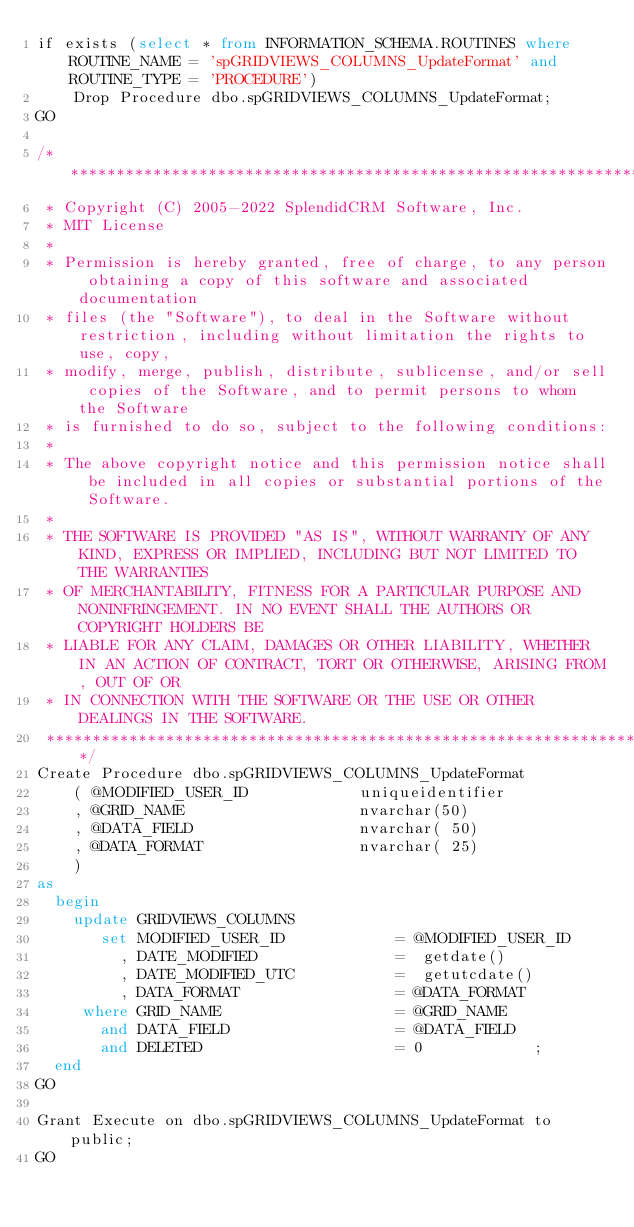Convert code to text. <code><loc_0><loc_0><loc_500><loc_500><_SQL_>if exists (select * from INFORMATION_SCHEMA.ROUTINES where ROUTINE_NAME = 'spGRIDVIEWS_COLUMNS_UpdateFormat' and ROUTINE_TYPE = 'PROCEDURE')
	Drop Procedure dbo.spGRIDVIEWS_COLUMNS_UpdateFormat;
GO
 
/**********************************************************************************************************************
 * Copyright (C) 2005-2022 SplendidCRM Software, Inc. 
 * MIT License
 * 
 * Permission is hereby granted, free of charge, to any person obtaining a copy of this software and associated documentation 
 * files (the "Software"), to deal in the Software without restriction, including without limitation the rights to use, copy, 
 * modify, merge, publish, distribute, sublicense, and/or sell copies of the Software, and to permit persons to whom the Software 
 * is furnished to do so, subject to the following conditions:
 * 
 * The above copyright notice and this permission notice shall be included in all copies or substantial portions of the Software.
 * 
 * THE SOFTWARE IS PROVIDED "AS IS", WITHOUT WARRANTY OF ANY KIND, EXPRESS OR IMPLIED, INCLUDING BUT NOT LIMITED TO THE WARRANTIES 
 * OF MERCHANTABILITY, FITNESS FOR A PARTICULAR PURPOSE AND NONINFRINGEMENT. IN NO EVENT SHALL THE AUTHORS OR COPYRIGHT HOLDERS BE 
 * LIABLE FOR ANY CLAIM, DAMAGES OR OTHER LIABILITY, WHETHER IN AN ACTION OF CONTRACT, TORT OR OTHERWISE, ARISING FROM, OUT OF OR 
 * IN CONNECTION WITH THE SOFTWARE OR THE USE OR OTHER DEALINGS IN THE SOFTWARE.
 *********************************************************************************************************************/
Create Procedure dbo.spGRIDVIEWS_COLUMNS_UpdateFormat
	( @MODIFIED_USER_ID            uniqueidentifier
	, @GRID_NAME                   nvarchar(50)
	, @DATA_FIELD                  nvarchar( 50)
	, @DATA_FORMAT                 nvarchar( 25)
	)
as
  begin
	update GRIDVIEWS_COLUMNS
	   set MODIFIED_USER_ID            = @MODIFIED_USER_ID 
	     , DATE_MODIFIED               =  getdate()        
	     , DATE_MODIFIED_UTC           =  getutcdate()     
	     , DATA_FORMAT                 = @DATA_FORMAT
	 where GRID_NAME                   = @GRID_NAME
	   and DATA_FIELD                  = @DATA_FIELD
	   and DELETED                     = 0            ;
  end
GO
 
Grant Execute on dbo.spGRIDVIEWS_COLUMNS_UpdateFormat to public;
GO
 
</code> 